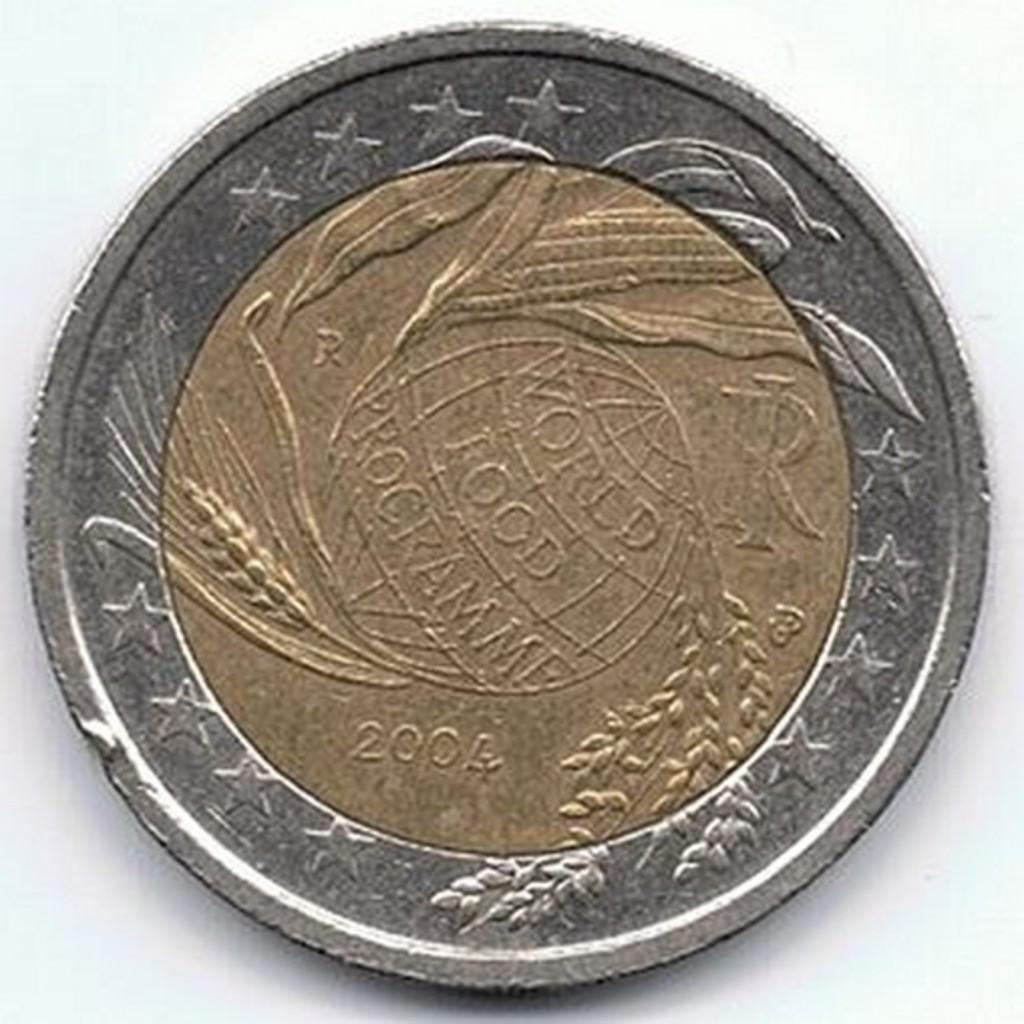Provide a one-sentence caption for the provided image. A gold and silver coin from 2004 sits on a white table. 